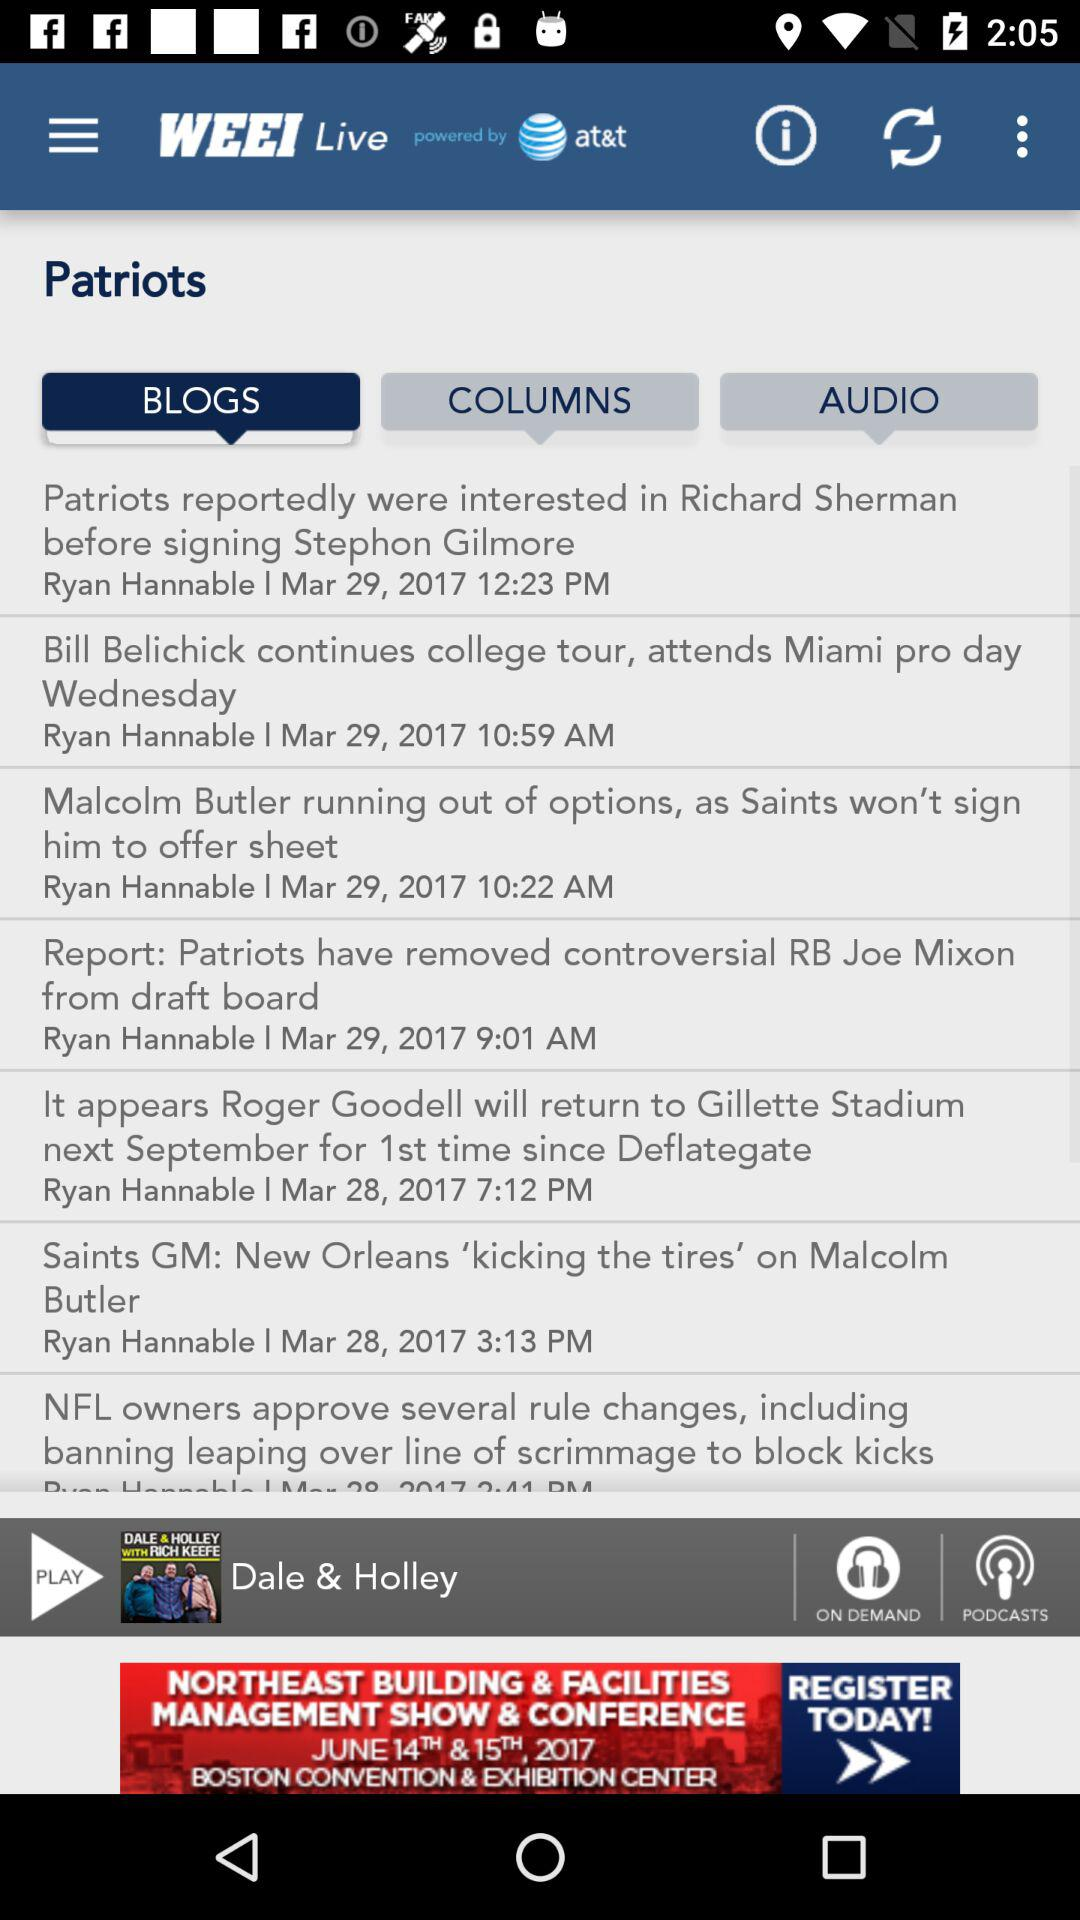Which blog was published at 10:59 p.m.? The blog that was published at 10:59 p.m. was "Bill Belichick continues college tour, attends Miami pro day Wednesday". 